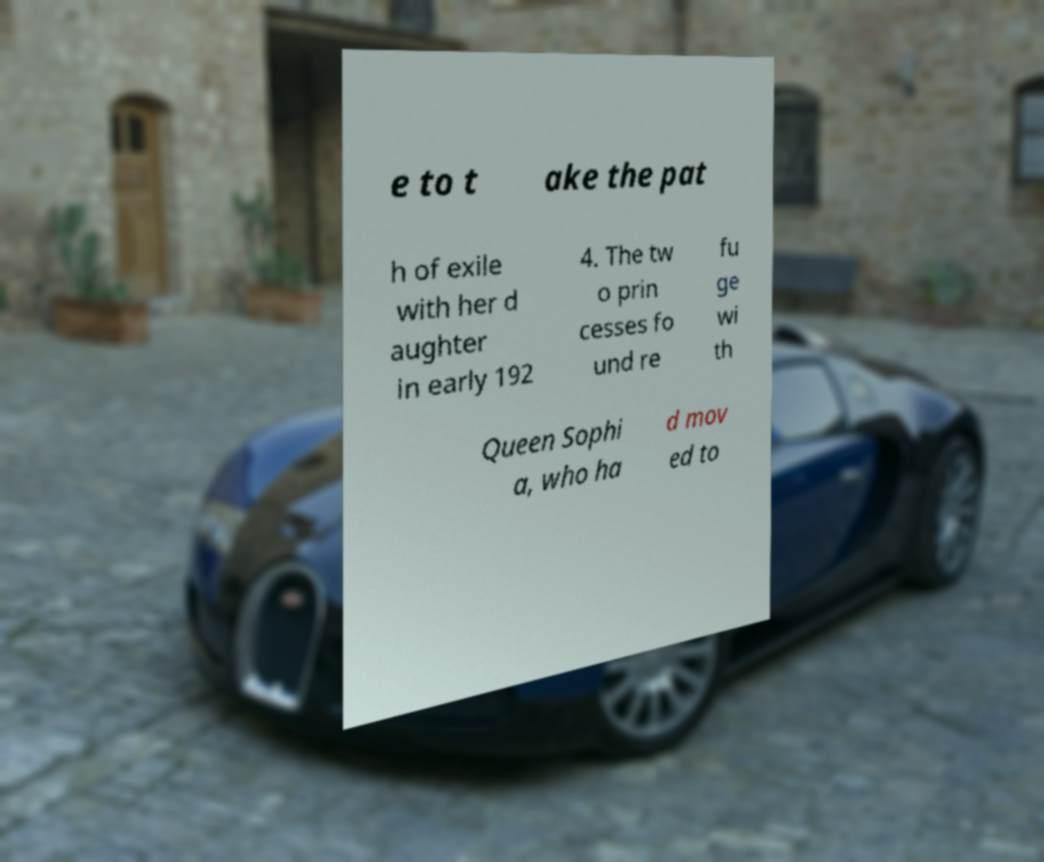For documentation purposes, I need the text within this image transcribed. Could you provide that? e to t ake the pat h of exile with her d aughter in early 192 4. The tw o prin cesses fo und re fu ge wi th Queen Sophi a, who ha d mov ed to 